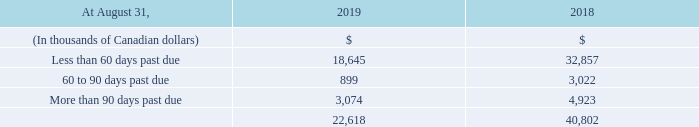Trade accounts receivable past due is defined as the amount outstanding beyond normal credit terms and conditions for the respective customers. A large portion of the Corporation’s customers are billed and pay before the services are rendered. The Corporation considers the amount outstanding at the due date as trade accounts receivable past due.
The following table provides further details on trade accounts receivable past due net of allowance for doubtful accounts at August 31, 2019 and 2018:
What is the definition of trade accounts receivable past due? Trade accounts receivable past due is defined as the amount outstanding beyond normal credit terms and conditions for the respective customers. What is the trade accounts receivable in 2019 less than 60 days past due?
Answer scale should be: thousand. 18,645. What is the trade accounts receivable in 2018 less than 60 days past due?
Answer scale should be: thousand. 32,857. What was the increase / (decrease) in trade accounts receivable less than 60 days past due?
Answer scale should be: thousand. 18,645 - 32,857
Answer: -14212. What was the average trade accounts receivable 60 to 90 days past due?
Answer scale should be: thousand. (899 + 3,022) / 2
Answer: 1960.5. What was the average trade accounts receivable more than 90 days past due?
Answer scale should be: thousand. (3,074 + 4,923) / 2
Answer: 3998.5. 